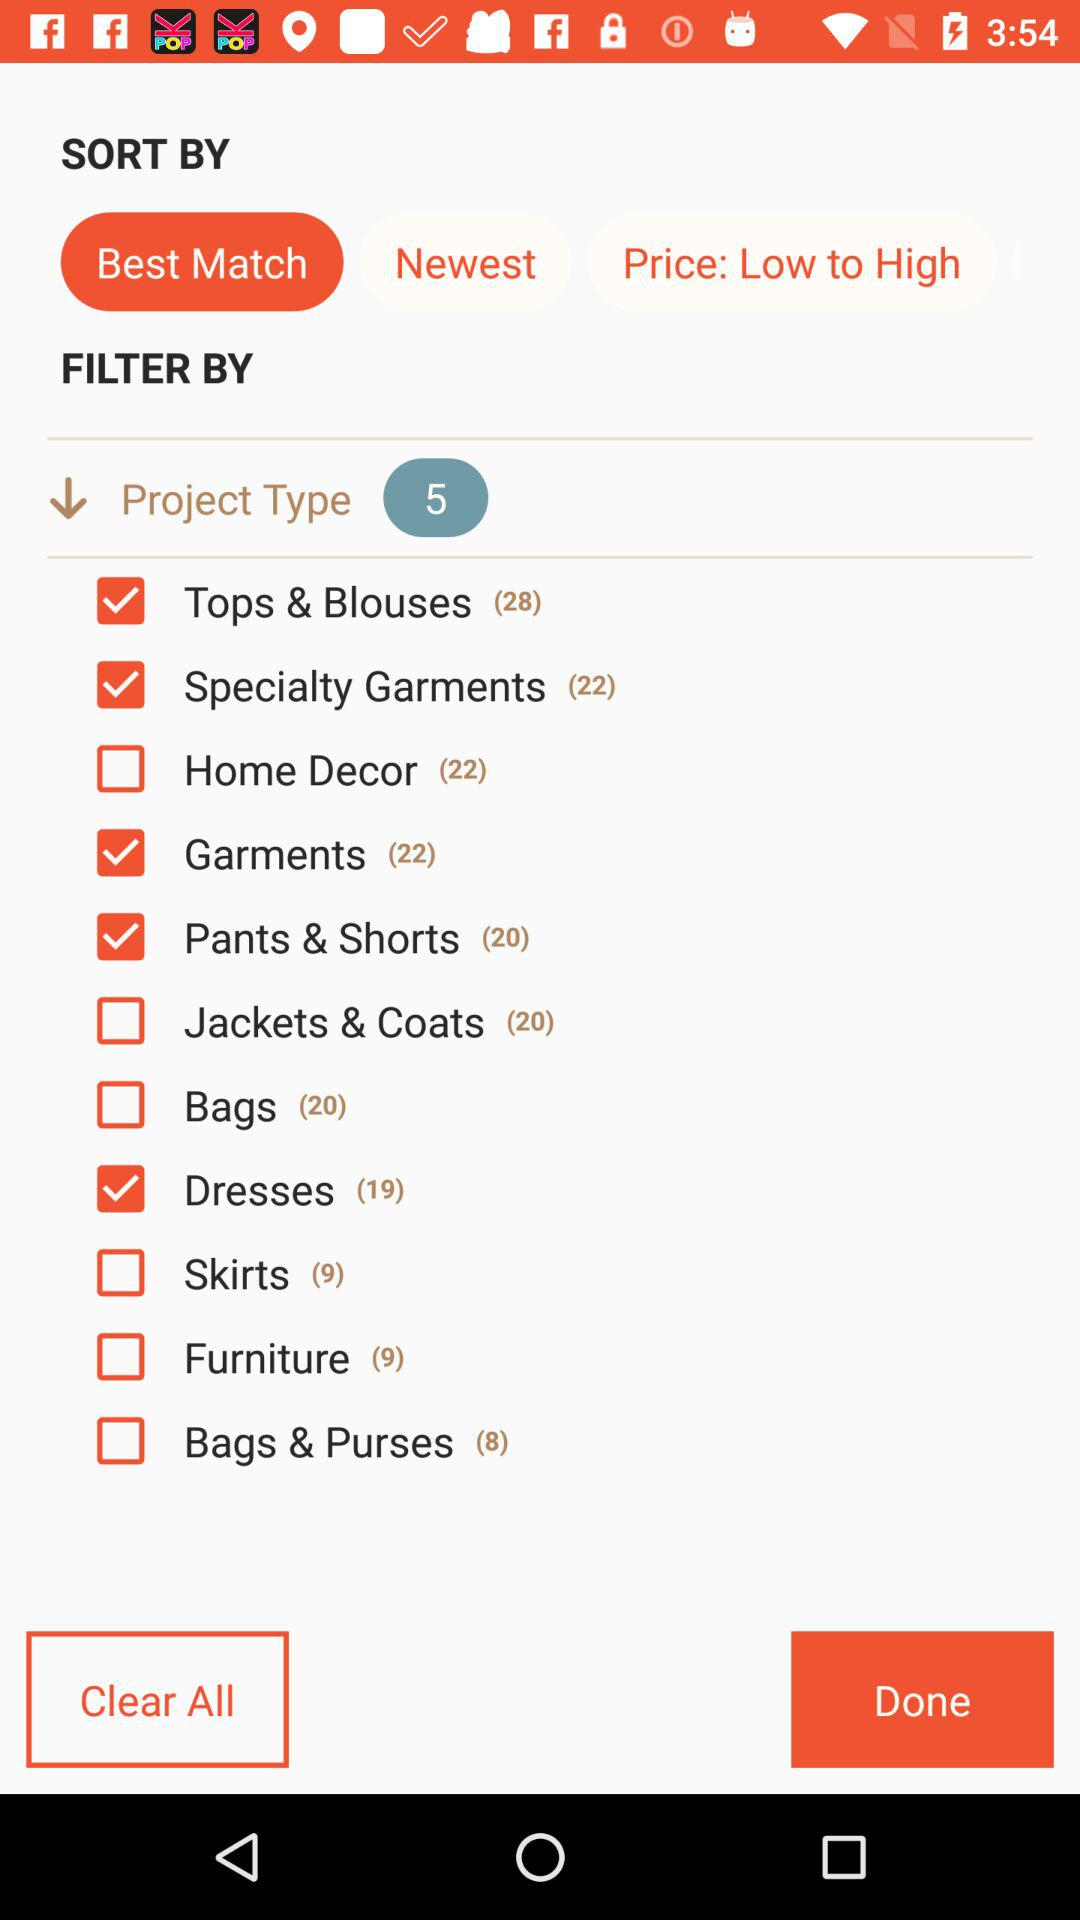What is the current state of "Bags"? The current state of "Bags" is unselected. 